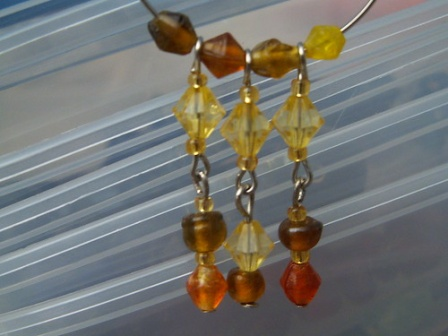What might the earrings symbolize in different cultural contexts? In some cultures, the combination of beads and silver may symbolize prosperity and good fortune. Brown beads can represent grounding and stability, yellow beads often symbolize happiness and energy, while red beads might signify passion and vitality. The silver chains could be interpreted as a symbol of connectivity and continuity, linking different aspects of life in harmony. These earrings, with their vibrant colors and elegant design, could thus evoke a sense of balance and holistic well-being, cherished in various cultural contexts. They not only serve as fashion accessories but also carry deeper meanings, making them treasured items in any cultural setting. 